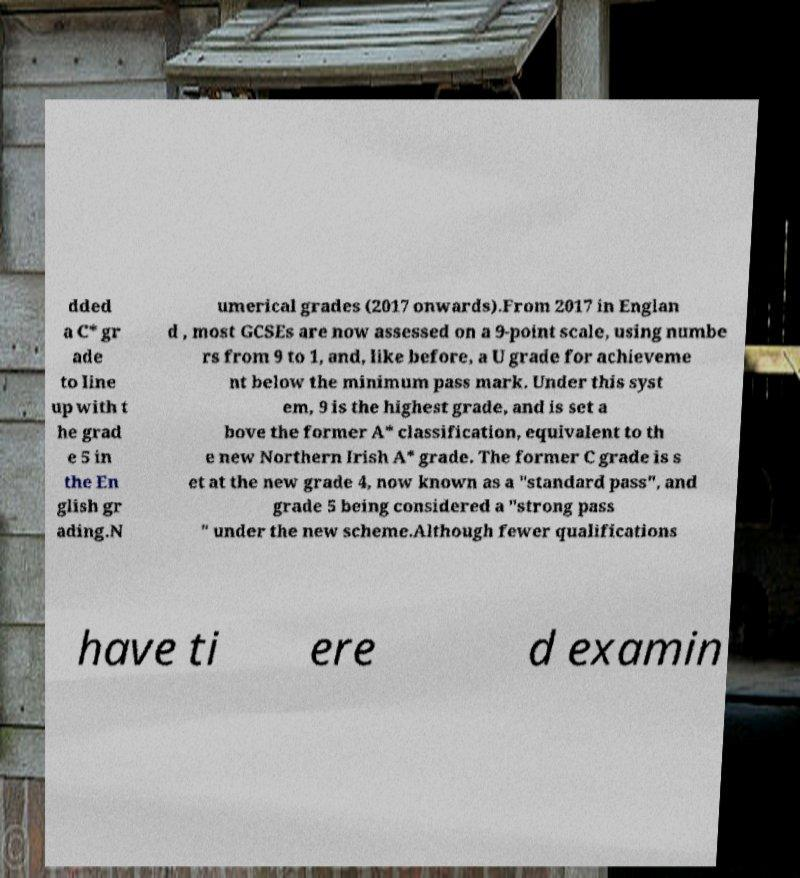Can you accurately transcribe the text from the provided image for me? dded a C* gr ade to line up with t he grad e 5 in the En glish gr ading.N umerical grades (2017 onwards).From 2017 in Englan d , most GCSEs are now assessed on a 9-point scale, using numbe rs from 9 to 1, and, like before, a U grade for achieveme nt below the minimum pass mark. Under this syst em, 9 is the highest grade, and is set a bove the former A* classification, equivalent to th e new Northern Irish A* grade. The former C grade is s et at the new grade 4, now known as a "standard pass", and grade 5 being considered a "strong pass " under the new scheme.Although fewer qualifications have ti ere d examin 